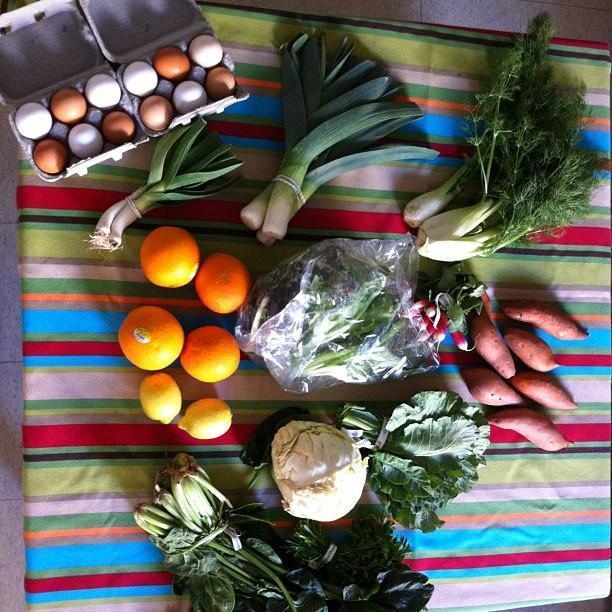How many different food groups are there?
Give a very brief answer. 3. How many lemons are there?
Give a very brief answer. 2. How many oranges are there?
Give a very brief answer. 4. How many hospital beds are there?
Give a very brief answer. 0. 